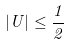Convert formula to latex. <formula><loc_0><loc_0><loc_500><loc_500>| U | \leq \frac { 1 } { 2 }</formula> 